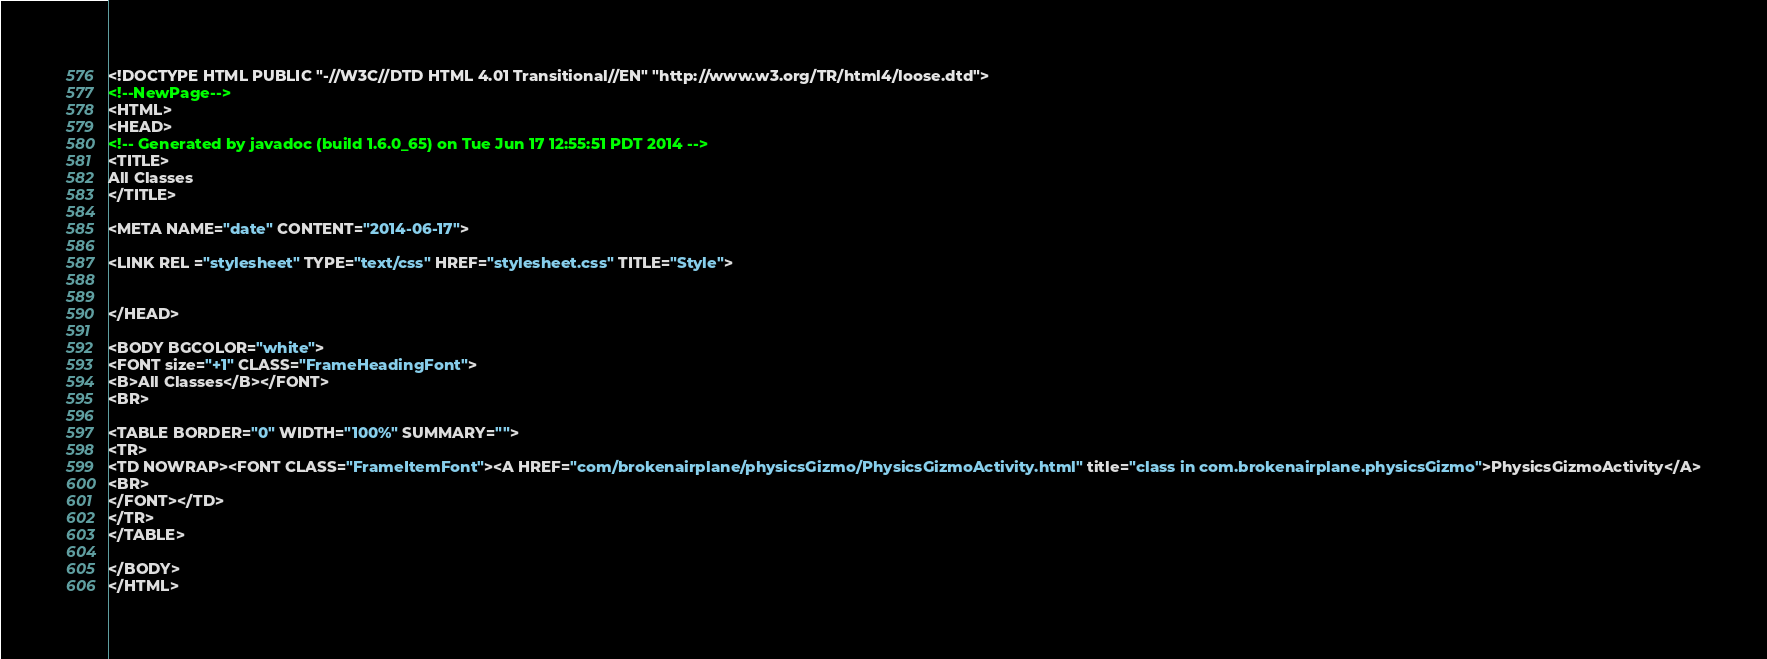Convert code to text. <code><loc_0><loc_0><loc_500><loc_500><_HTML_><!DOCTYPE HTML PUBLIC "-//W3C//DTD HTML 4.01 Transitional//EN" "http://www.w3.org/TR/html4/loose.dtd">
<!--NewPage-->
<HTML>
<HEAD>
<!-- Generated by javadoc (build 1.6.0_65) on Tue Jun 17 12:55:51 PDT 2014 -->
<TITLE>
All Classes
</TITLE>

<META NAME="date" CONTENT="2014-06-17">

<LINK REL ="stylesheet" TYPE="text/css" HREF="stylesheet.css" TITLE="Style">


</HEAD>

<BODY BGCOLOR="white">
<FONT size="+1" CLASS="FrameHeadingFont">
<B>All Classes</B></FONT>
<BR>

<TABLE BORDER="0" WIDTH="100%" SUMMARY="">
<TR>
<TD NOWRAP><FONT CLASS="FrameItemFont"><A HREF="com/brokenairplane/physicsGizmo/PhysicsGizmoActivity.html" title="class in com.brokenairplane.physicsGizmo">PhysicsGizmoActivity</A>
<BR>
</FONT></TD>
</TR>
</TABLE>

</BODY>
</HTML>
</code> 